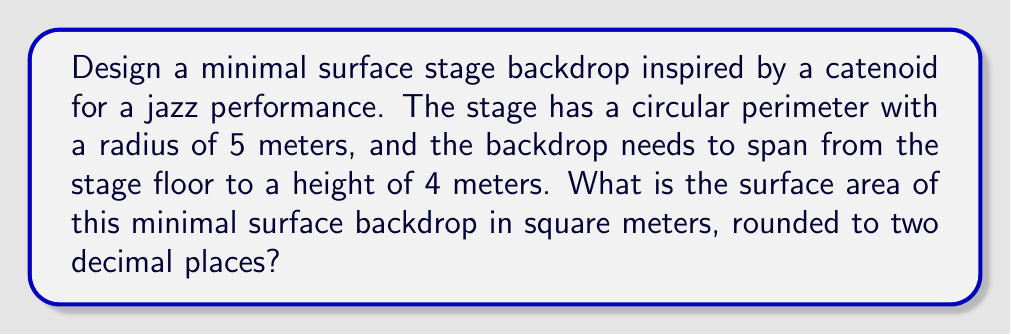Teach me how to tackle this problem. To solve this problem, we'll follow these steps:

1) The minimal surface that spans between two circular rings is a catenoid. The surface area of a catenoid is given by the formula:

   $$A = 2\pi c^2 \left(\sinh\left(\frac{h}{c}\right) - \frac{h}{c}\right)$$

   where $c$ is the catenary constant and $h$ is half the height of the catenoid.

2) In our case, $h = 2$ meters (half of 4 meters).

3) To find $c$, we need to use the equation of the catenary curve:

   $$r = c \cosh\left(\frac{z}{c}\right)$$

   where $r$ is the radius at height $z$.

4) At $z = h = 2$, $r = 5$. So we have:

   $$5 = c \cosh\left(\frac{2}{c}\right)$$

5) This equation can't be solved analytically. We need to use numerical methods. Using a computer or calculator, we find:

   $c \approx 2.7685$

6) Now we can substitute this value of $c$ and $h = 2$ into the surface area formula:

   $$A = 2\pi (2.7685)^2 \left(\sinh\left(\frac{2}{2.7685}\right) - \frac{2}{2.7685}\right)$$

7) Calculating this:

   $$A \approx 104.72 \text{ square meters}$$

8) Rounding to two decimal places:

   $$A \approx 104.72 \text{ square meters}$$
Answer: 104.72 square meters 